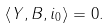<formula> <loc_0><loc_0><loc_500><loc_500>\left \langle Y , B , i _ { 0 } \right \rangle = 0 .</formula> 